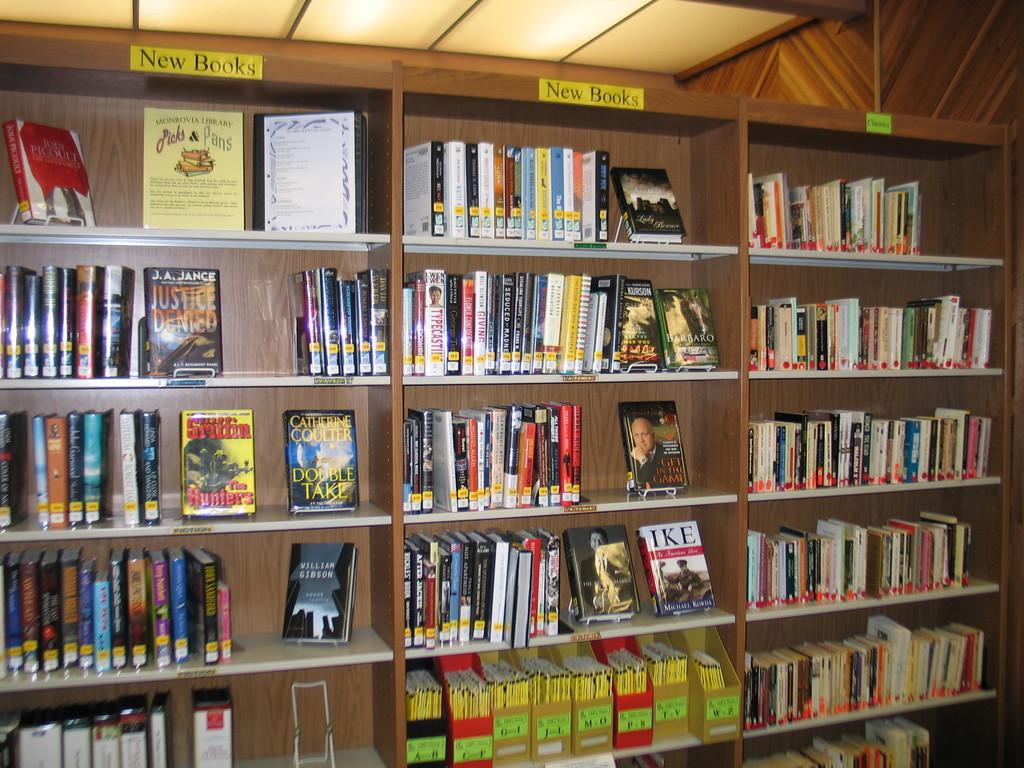What type of objects can be seen on the shelves in the image? There are books in the shelves. What additional items can be found in the image? There are stickers and lights visible in the image. What structure is present above the shelves? There is a roof visible in the image. What type of boats are visible in the image? There are no boats present in the image. What message is being conveyed by the good-bye in the image? There is no good-bye or any indication of a message being conveyed in the image. 